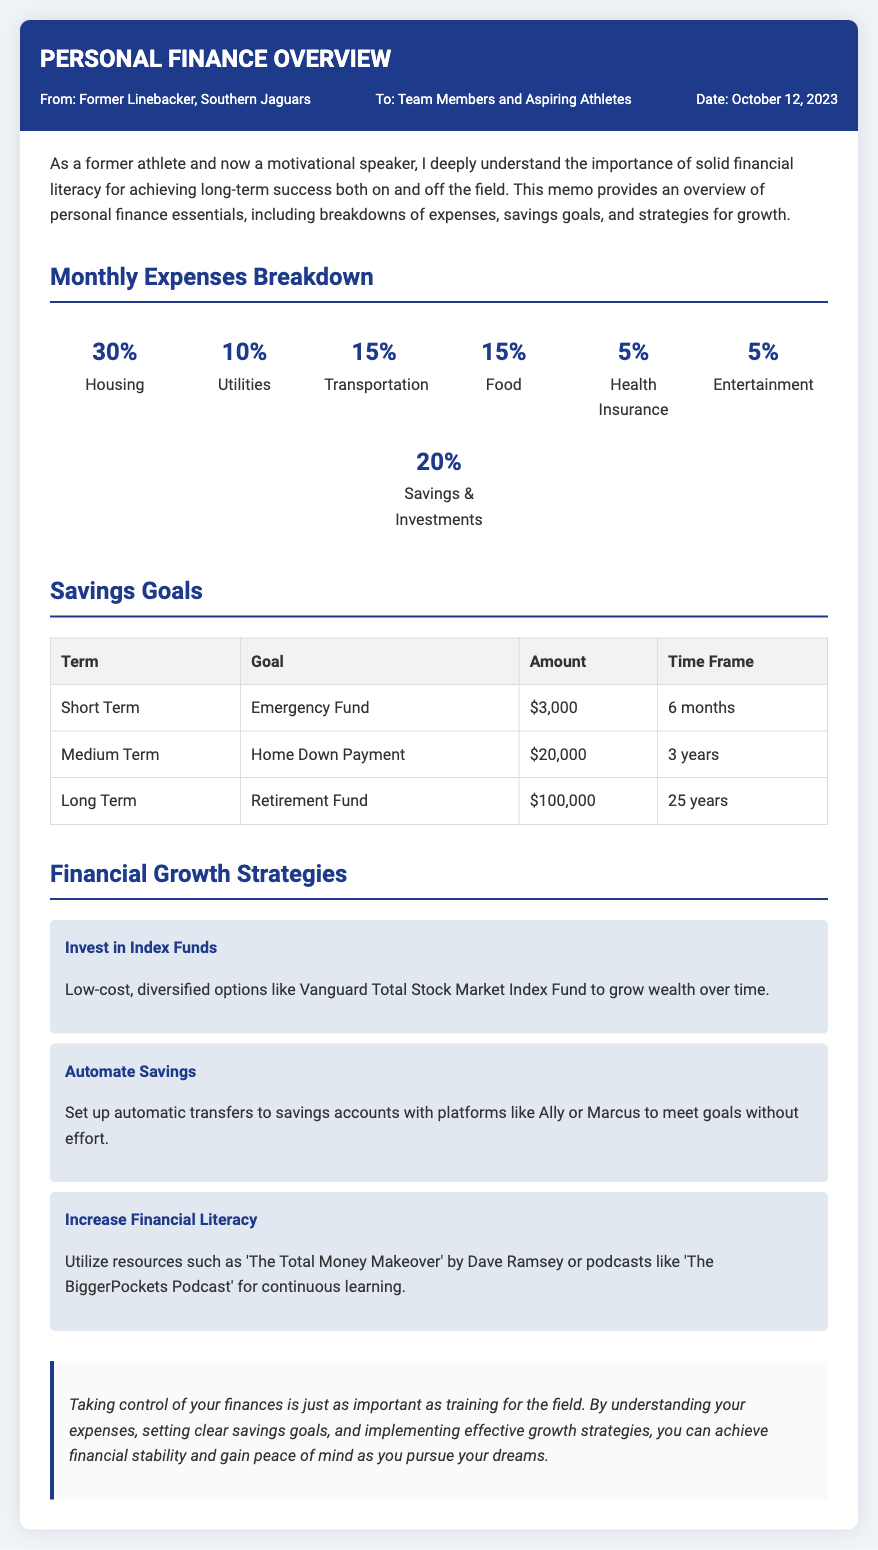what is the date of the memo? The date of the memo is mentioned in the meta section, which states "Date: October 12, 2023."
Answer: October 12, 2023 what percentage of monthly expenses goes to housing? The breakdown lists housing as 30% of monthly expenses.
Answer: 30% how much should you save for an emergency fund? The savings goals section specifies that the emergency fund goal is $3,000.
Answer: $3,000 what is the long-term retirement fund goal amount? The long-term goal for the retirement fund is detailed in the savings goals section, which states it is $100,000.
Answer: $100,000 which strategy suggests using low-cost investment options? The financial growth strategies section mentions "Invest in Index Funds" as a strategy using low-cost options.
Answer: Invest in Index Funds how long is the timeframe to achieve the home down payment goal? The savings goals section specifies that the timeframe for the home down payment goal is 3 years.
Answer: 3 years what is the percentage allocated for savings and investments in monthly expenses? The expense breakdown lists savings & investments as 20% of monthly expenses.
Answer: 20% which resource is mentioned for increasing financial literacy? The document suggests using "The Total Money Makeover" by Dave Ramsey as a resource for financial literacy.
Answer: The Total Money Makeover what is the percentage of monthly expenses allocated for entertainment? The expenses section indicates that entertainment accounts for 5% of monthly expenses.
Answer: 5% 